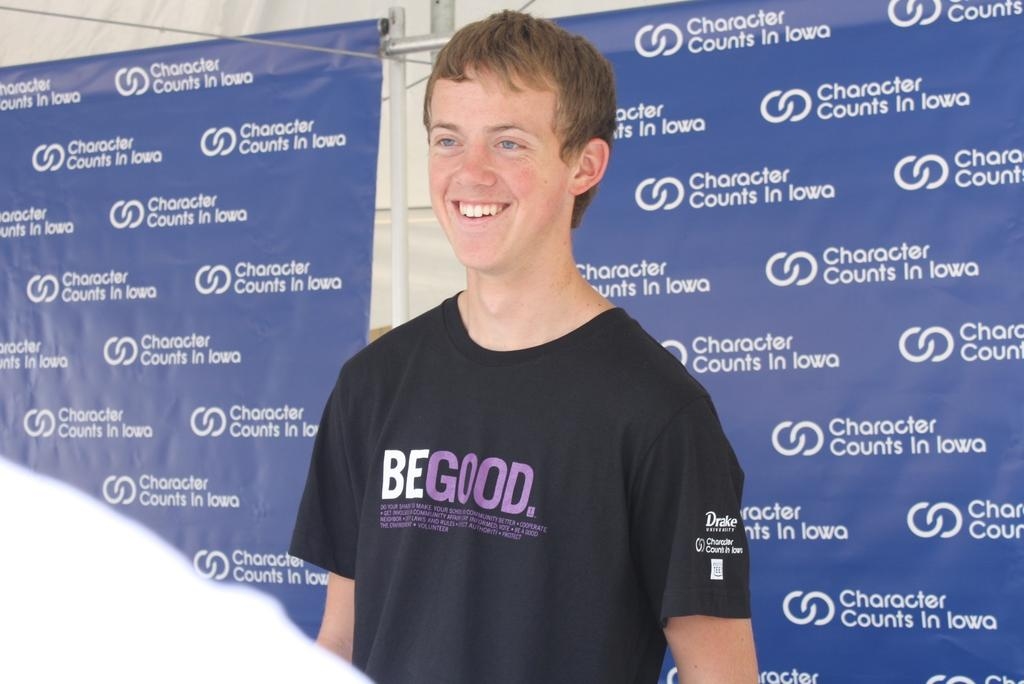Provide a one-sentence caption for the provided image. A young man smiles while wearing a Be Good t-shirt. 